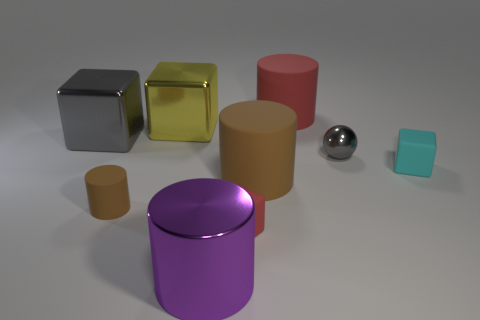There is a cylinder behind the block on the right side of the gray object on the right side of the big metal cylinder; what is its size?
Give a very brief answer. Large. Is there a yellow shiny object that is to the left of the shiny thing on the right side of the big red matte cylinder?
Your answer should be compact. Yes. Does the yellow shiny thing have the same shape as the tiny object on the right side of the tiny gray metallic ball?
Your answer should be very brief. Yes. What color is the tiny cube left of the red cylinder?
Offer a very short reply. Red. There is a brown cylinder to the right of the brown object left of the large purple metal object; what size is it?
Your answer should be compact. Large. There is a red object that is behind the yellow metallic block; is its shape the same as the large brown thing?
Give a very brief answer. Yes. What material is the small brown thing that is the same shape as the large red rubber object?
Offer a very short reply. Rubber. How many objects are either tiny things to the left of the purple metallic cylinder or matte cylinders that are left of the big shiny cylinder?
Make the answer very short. 1. There is a tiny sphere; does it have the same color as the big cube that is to the left of the yellow shiny block?
Provide a succinct answer. Yes. The large gray thing that is made of the same material as the big purple cylinder is what shape?
Your answer should be very brief. Cube. 